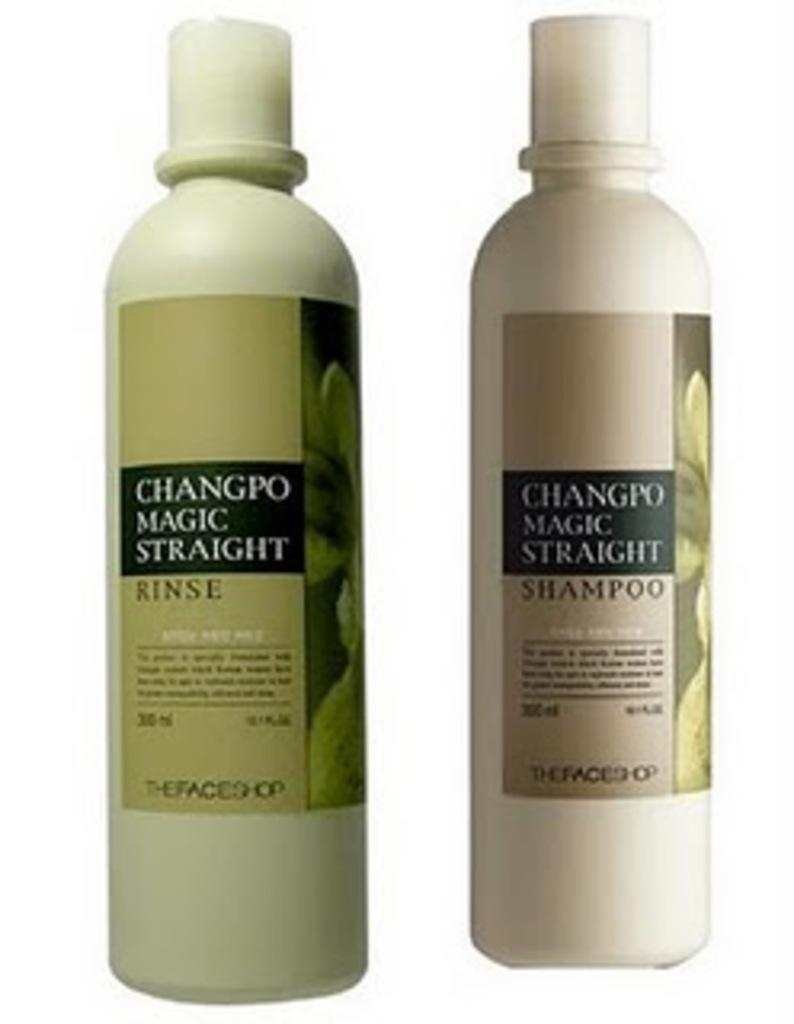<image>
Present a compact description of the photo's key features. Two full size bottles of hair products from Changpo Magic Straight shown. 